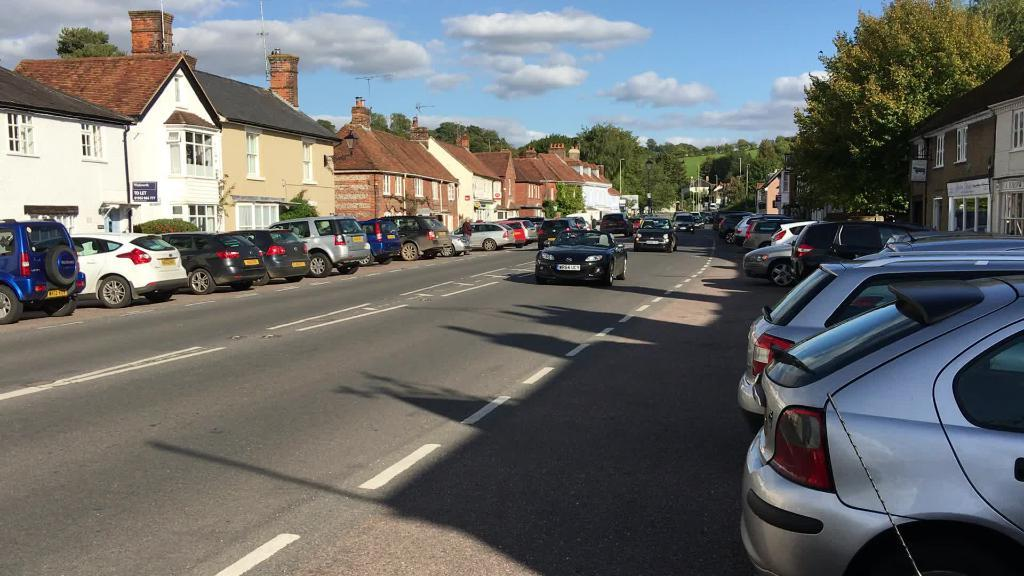What can be seen on the road in the image? There are vehicles parked on the road, and cars are moving on the road. What else is visible in the image besides the road? There are buildings and trees in the image. How would you describe the sky in the image? The sky is cloudy in the image. Where is the nut located in the image? There is no nut present in the image. What type of gate can be seen in the image? There is no gate present in the image. 